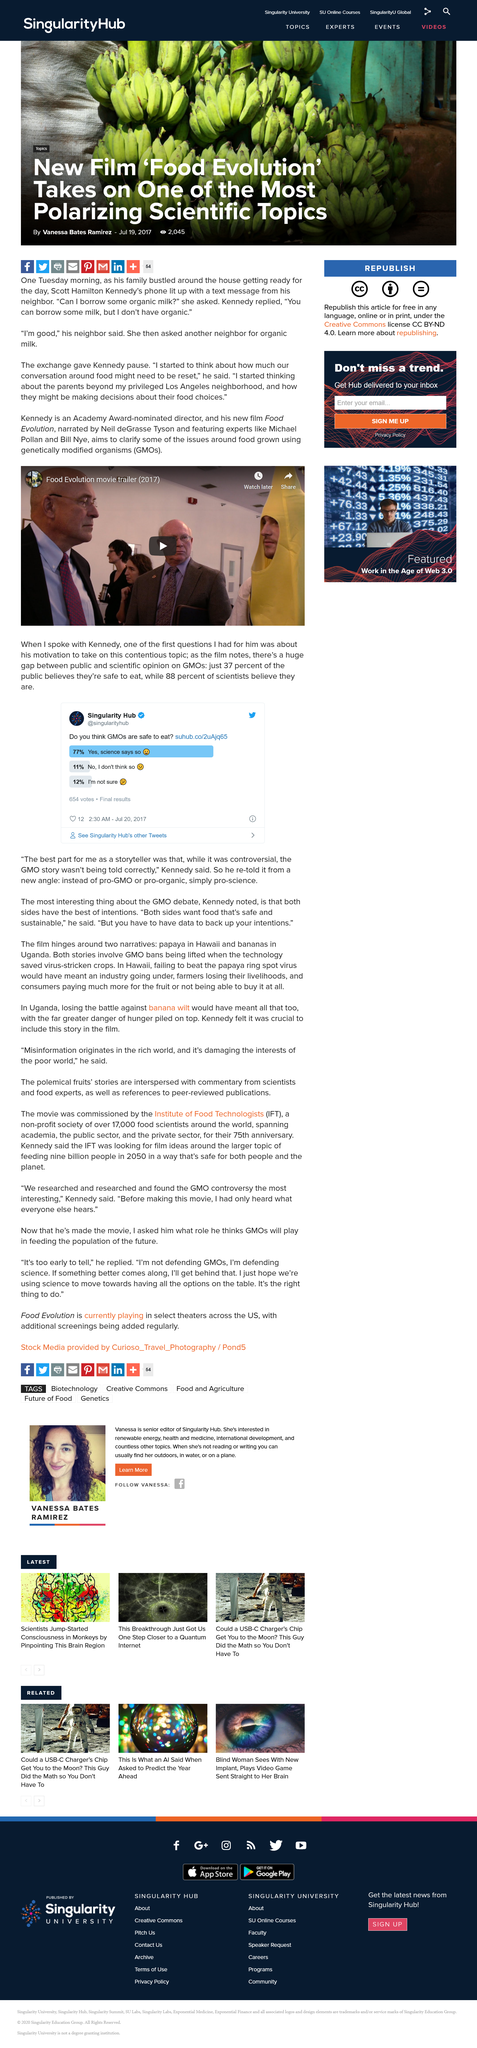Identify some key points in this picture. The title of the video is "Food Evolution movie trailer (2017)". According to the poll on the Singularity Hub website, 12% of the respondents were unsure if consuming genetically modified organisms (GMOs) was safe. The video is shareable and can be shared with others. According to a survey conducted by Kennedy, it was found that 37% of the general public believes that GMOs are safe to eat. Scientists overwhelmingly support the safety of GMOs for consumption. 